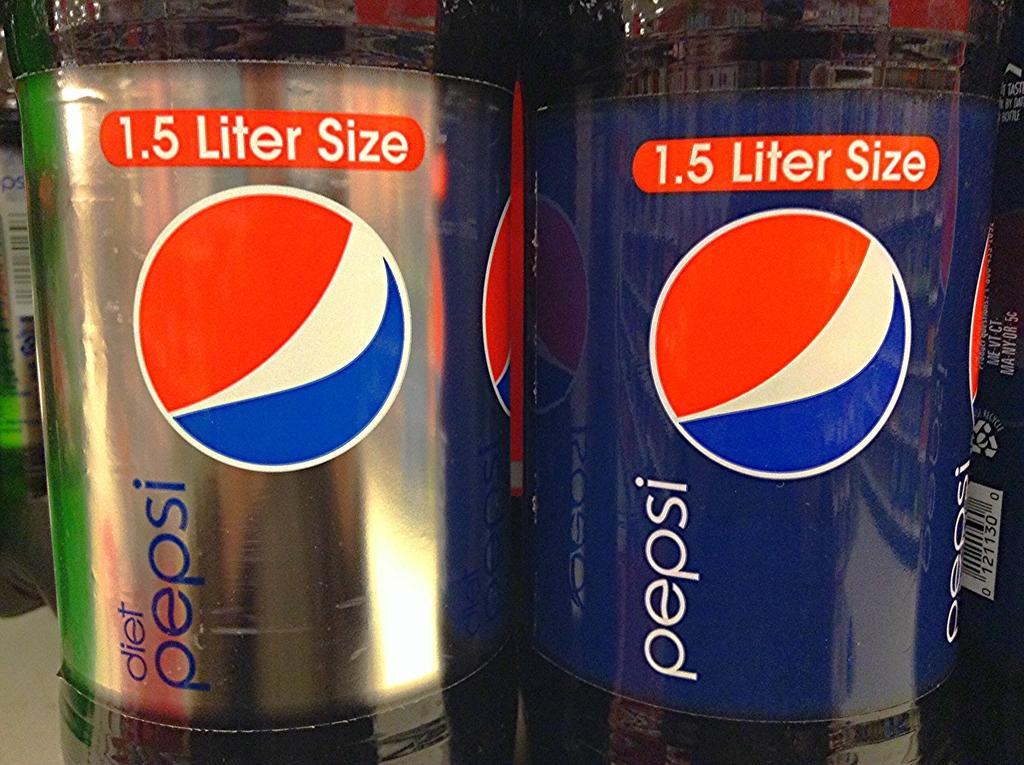<image>
Describe the image concisely. A 1.5 liter bottle of Diet Pepsi stands next to a 1.5 liter bottle of Pepsi. 